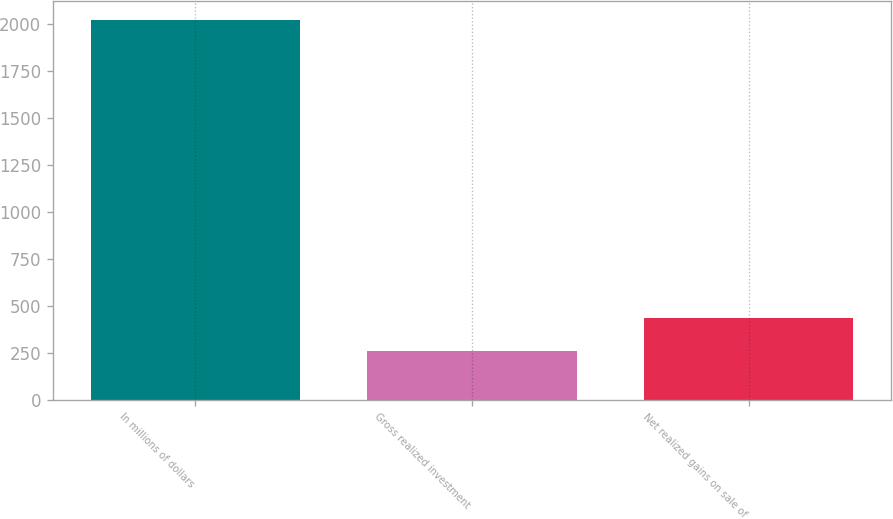Convert chart to OTSL. <chart><loc_0><loc_0><loc_500><loc_500><bar_chart><fcel>In millions of dollars<fcel>Gross realized investment<fcel>Net realized gains on sale of<nl><fcel>2018<fcel>261<fcel>436.7<nl></chart> 